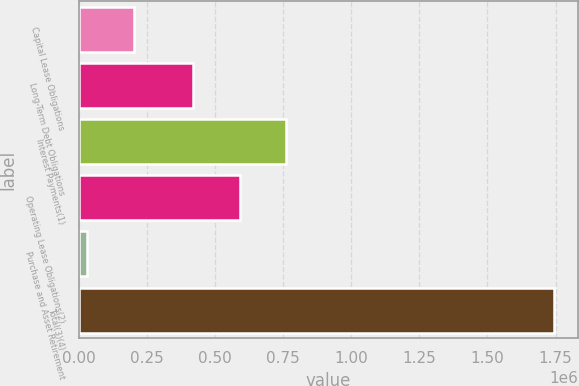Convert chart. <chart><loc_0><loc_0><loc_500><loc_500><bar_chart><fcel>Capital Lease Obligations<fcel>Long-Term Debt Obligations<fcel>Interest Payments(1)<fcel>Operating Lease Obligations(2)<fcel>Purchase and Asset Retirement<fcel>Total(3)(4)<nl><fcel>202052<fcel>418365<fcel>761445<fcel>589905<fcel>30512<fcel>1.74591e+06<nl></chart> 